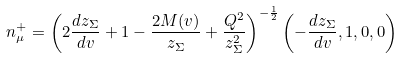Convert formula to latex. <formula><loc_0><loc_0><loc_500><loc_500>n ^ { + } _ { \mu } = \left ( 2 \frac { d z _ { \Sigma } } { d v } + 1 - \frac { 2 M ( v ) } { z _ { \Sigma } } + \frac { Q ^ { 2 } } { z _ { \Sigma } ^ { 2 } } \right ) ^ { - \frac { 1 } { 2 } } \left ( - \frac { d z _ { \Sigma } } { d v } , 1 , 0 , 0 \right )</formula> 